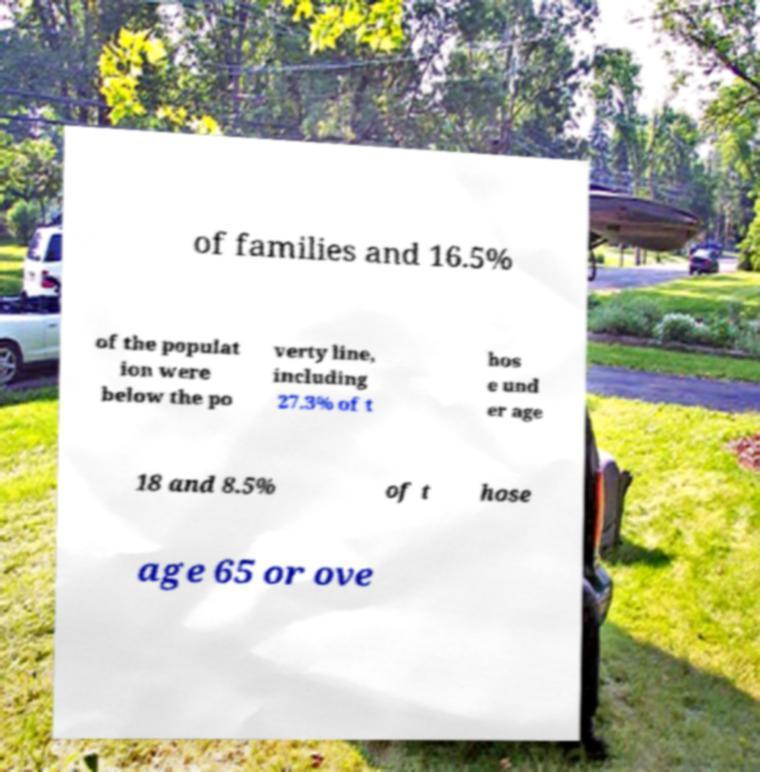Can you accurately transcribe the text from the provided image for me? of families and 16.5% of the populat ion were below the po verty line, including 27.3% of t hos e und er age 18 and 8.5% of t hose age 65 or ove 